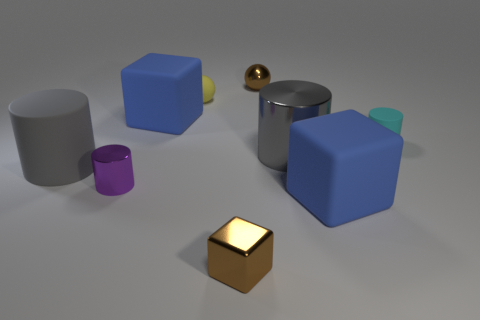Subtract 1 cylinders. How many cylinders are left? 3 Add 1 tiny yellow objects. How many objects exist? 10 Subtract all cubes. How many objects are left? 6 Subtract all brown metallic blocks. Subtract all large gray rubber cylinders. How many objects are left? 7 Add 5 tiny cyan cylinders. How many tiny cyan cylinders are left? 6 Add 5 big green cylinders. How many big green cylinders exist? 5 Subtract 0 yellow blocks. How many objects are left? 9 